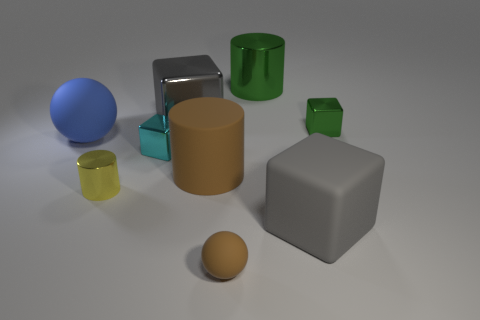There is a small green object that is the same shape as the gray matte object; what material is it?
Give a very brief answer. Metal. What number of green blocks are the same size as the cyan block?
Give a very brief answer. 1. The yellow metal object has what shape?
Give a very brief answer. Cylinder. There is a rubber object that is right of the big metal cube and behind the rubber cube; how big is it?
Your answer should be compact. Large. There is a small block that is on the left side of the brown sphere; what is it made of?
Provide a short and direct response. Metal. Does the big metallic cube have the same color as the small cube that is on the left side of the tiny green metallic cube?
Offer a very short reply. No. What number of objects are either big cubes on the right side of the green cylinder or rubber objects to the left of the green cylinder?
Offer a very short reply. 4. The small thing that is both behind the yellow metallic cylinder and to the left of the large brown thing is what color?
Your response must be concise. Cyan. Is the number of big matte blocks greater than the number of brown metal cylinders?
Your answer should be compact. Yes. There is a large gray thing that is in front of the blue object; does it have the same shape as the tiny green object?
Provide a short and direct response. Yes. 